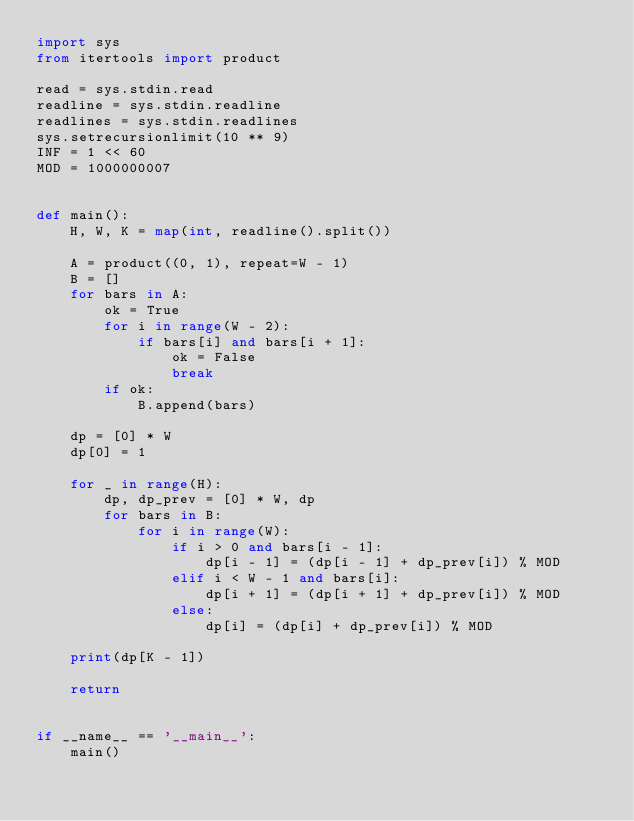Convert code to text. <code><loc_0><loc_0><loc_500><loc_500><_Python_>import sys
from itertools import product

read = sys.stdin.read
readline = sys.stdin.readline
readlines = sys.stdin.readlines
sys.setrecursionlimit(10 ** 9)
INF = 1 << 60
MOD = 1000000007


def main():
    H, W, K = map(int, readline().split())

    A = product((0, 1), repeat=W - 1)
    B = []
    for bars in A:
        ok = True
        for i in range(W - 2):
            if bars[i] and bars[i + 1]:
                ok = False
                break
        if ok:
            B.append(bars)

    dp = [0] * W
    dp[0] = 1

    for _ in range(H):
        dp, dp_prev = [0] * W, dp
        for bars in B:
            for i in range(W):
                if i > 0 and bars[i - 1]:
                    dp[i - 1] = (dp[i - 1] + dp_prev[i]) % MOD
                elif i < W - 1 and bars[i]:
                    dp[i + 1] = (dp[i + 1] + dp_prev[i]) % MOD
                else:
                    dp[i] = (dp[i] + dp_prev[i]) % MOD

    print(dp[K - 1])

    return


if __name__ == '__main__':
    main()
</code> 